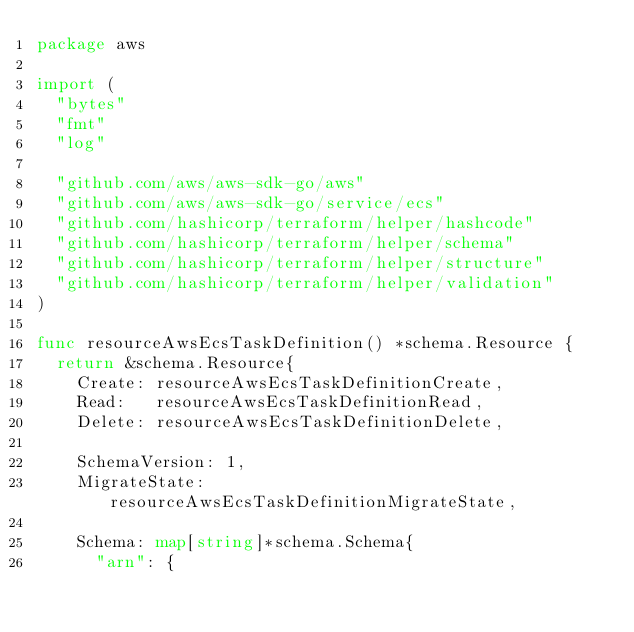Convert code to text. <code><loc_0><loc_0><loc_500><loc_500><_Go_>package aws

import (
	"bytes"
	"fmt"
	"log"

	"github.com/aws/aws-sdk-go/aws"
	"github.com/aws/aws-sdk-go/service/ecs"
	"github.com/hashicorp/terraform/helper/hashcode"
	"github.com/hashicorp/terraform/helper/schema"
	"github.com/hashicorp/terraform/helper/structure"
	"github.com/hashicorp/terraform/helper/validation"
)

func resourceAwsEcsTaskDefinition() *schema.Resource {
	return &schema.Resource{
		Create: resourceAwsEcsTaskDefinitionCreate,
		Read:   resourceAwsEcsTaskDefinitionRead,
		Delete: resourceAwsEcsTaskDefinitionDelete,

		SchemaVersion: 1,
		MigrateState:  resourceAwsEcsTaskDefinitionMigrateState,

		Schema: map[string]*schema.Schema{
			"arn": {</code> 